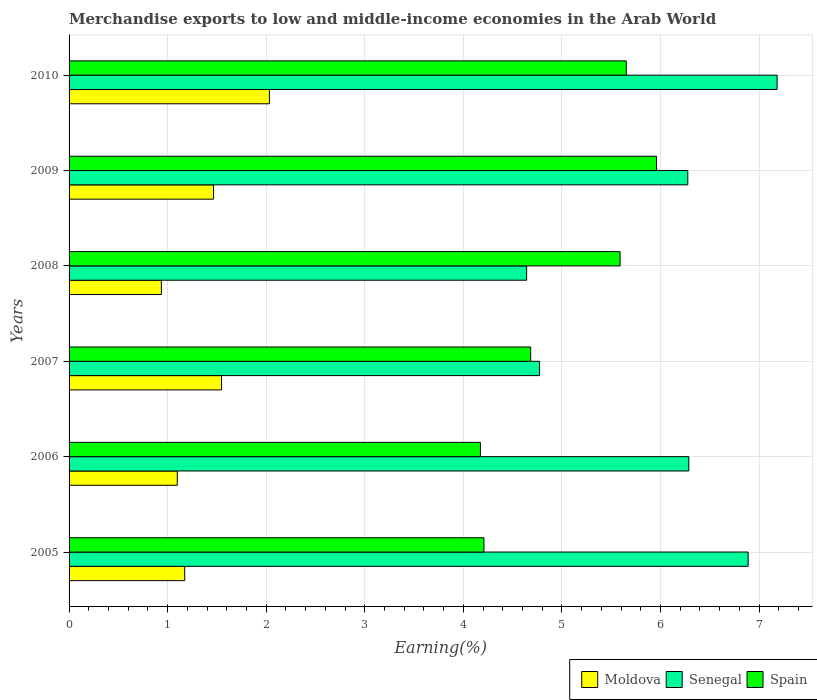Are the number of bars per tick equal to the number of legend labels?
Provide a short and direct response. Yes. Are the number of bars on each tick of the Y-axis equal?
Give a very brief answer. Yes. How many bars are there on the 1st tick from the bottom?
Offer a very short reply. 3. In how many cases, is the number of bars for a given year not equal to the number of legend labels?
Offer a terse response. 0. What is the percentage of amount earned from merchandise exports in Senegal in 2008?
Give a very brief answer. 4.64. Across all years, what is the maximum percentage of amount earned from merchandise exports in Moldova?
Offer a terse response. 2.03. Across all years, what is the minimum percentage of amount earned from merchandise exports in Moldova?
Make the answer very short. 0.94. In which year was the percentage of amount earned from merchandise exports in Senegal maximum?
Ensure brevity in your answer.  2010. In which year was the percentage of amount earned from merchandise exports in Spain minimum?
Provide a succinct answer. 2006. What is the total percentage of amount earned from merchandise exports in Moldova in the graph?
Your answer should be compact. 8.25. What is the difference between the percentage of amount earned from merchandise exports in Senegal in 2006 and that in 2008?
Keep it short and to the point. 1.65. What is the difference between the percentage of amount earned from merchandise exports in Senegal in 2006 and the percentage of amount earned from merchandise exports in Spain in 2009?
Your answer should be very brief. 0.33. What is the average percentage of amount earned from merchandise exports in Senegal per year?
Make the answer very short. 6.01. In the year 2008, what is the difference between the percentage of amount earned from merchandise exports in Spain and percentage of amount earned from merchandise exports in Senegal?
Make the answer very short. 0.95. In how many years, is the percentage of amount earned from merchandise exports in Moldova greater than 6.8 %?
Make the answer very short. 0. What is the ratio of the percentage of amount earned from merchandise exports in Spain in 2008 to that in 2009?
Provide a short and direct response. 0.94. What is the difference between the highest and the second highest percentage of amount earned from merchandise exports in Senegal?
Your answer should be very brief. 0.29. What is the difference between the highest and the lowest percentage of amount earned from merchandise exports in Spain?
Keep it short and to the point. 1.79. Is the sum of the percentage of amount earned from merchandise exports in Moldova in 2008 and 2010 greater than the maximum percentage of amount earned from merchandise exports in Spain across all years?
Keep it short and to the point. No. What does the 2nd bar from the top in 2007 represents?
Offer a very short reply. Senegal. Is it the case that in every year, the sum of the percentage of amount earned from merchandise exports in Moldova and percentage of amount earned from merchandise exports in Spain is greater than the percentage of amount earned from merchandise exports in Senegal?
Your answer should be compact. No. Are all the bars in the graph horizontal?
Your answer should be compact. Yes. How many years are there in the graph?
Ensure brevity in your answer.  6. What is the difference between two consecutive major ticks on the X-axis?
Keep it short and to the point. 1. Are the values on the major ticks of X-axis written in scientific E-notation?
Ensure brevity in your answer.  No. How many legend labels are there?
Provide a short and direct response. 3. What is the title of the graph?
Make the answer very short. Merchandise exports to low and middle-income economies in the Arab World. What is the label or title of the X-axis?
Provide a short and direct response. Earning(%). What is the label or title of the Y-axis?
Your answer should be very brief. Years. What is the Earning(%) in Moldova in 2005?
Provide a short and direct response. 1.17. What is the Earning(%) in Senegal in 2005?
Make the answer very short. 6.89. What is the Earning(%) in Spain in 2005?
Your response must be concise. 4.21. What is the Earning(%) of Moldova in 2006?
Provide a short and direct response. 1.1. What is the Earning(%) of Senegal in 2006?
Offer a very short reply. 6.29. What is the Earning(%) of Spain in 2006?
Keep it short and to the point. 4.17. What is the Earning(%) of Moldova in 2007?
Your answer should be compact. 1.55. What is the Earning(%) in Senegal in 2007?
Your response must be concise. 4.77. What is the Earning(%) in Spain in 2007?
Make the answer very short. 4.68. What is the Earning(%) of Moldova in 2008?
Provide a succinct answer. 0.94. What is the Earning(%) in Senegal in 2008?
Provide a succinct answer. 4.64. What is the Earning(%) in Spain in 2008?
Make the answer very short. 5.59. What is the Earning(%) of Moldova in 2009?
Offer a terse response. 1.47. What is the Earning(%) of Senegal in 2009?
Make the answer very short. 6.28. What is the Earning(%) in Spain in 2009?
Provide a short and direct response. 5.96. What is the Earning(%) in Moldova in 2010?
Ensure brevity in your answer.  2.03. What is the Earning(%) in Senegal in 2010?
Your answer should be very brief. 7.18. What is the Earning(%) of Spain in 2010?
Provide a short and direct response. 5.65. Across all years, what is the maximum Earning(%) of Moldova?
Provide a succinct answer. 2.03. Across all years, what is the maximum Earning(%) in Senegal?
Offer a very short reply. 7.18. Across all years, what is the maximum Earning(%) of Spain?
Your answer should be compact. 5.96. Across all years, what is the minimum Earning(%) in Moldova?
Ensure brevity in your answer.  0.94. Across all years, what is the minimum Earning(%) of Senegal?
Ensure brevity in your answer.  4.64. Across all years, what is the minimum Earning(%) of Spain?
Your answer should be very brief. 4.17. What is the total Earning(%) in Moldova in the graph?
Keep it short and to the point. 8.25. What is the total Earning(%) in Senegal in the graph?
Your answer should be compact. 36.05. What is the total Earning(%) of Spain in the graph?
Your answer should be very brief. 30.27. What is the difference between the Earning(%) in Moldova in 2005 and that in 2006?
Your answer should be very brief. 0.08. What is the difference between the Earning(%) of Senegal in 2005 and that in 2006?
Provide a short and direct response. 0.6. What is the difference between the Earning(%) in Spain in 2005 and that in 2006?
Your answer should be very brief. 0.04. What is the difference between the Earning(%) in Moldova in 2005 and that in 2007?
Make the answer very short. -0.37. What is the difference between the Earning(%) of Senegal in 2005 and that in 2007?
Provide a succinct answer. 2.12. What is the difference between the Earning(%) of Spain in 2005 and that in 2007?
Make the answer very short. -0.47. What is the difference between the Earning(%) of Moldova in 2005 and that in 2008?
Provide a succinct answer. 0.24. What is the difference between the Earning(%) in Senegal in 2005 and that in 2008?
Ensure brevity in your answer.  2.25. What is the difference between the Earning(%) in Spain in 2005 and that in 2008?
Ensure brevity in your answer.  -1.38. What is the difference between the Earning(%) in Moldova in 2005 and that in 2009?
Offer a terse response. -0.29. What is the difference between the Earning(%) in Senegal in 2005 and that in 2009?
Your answer should be very brief. 0.61. What is the difference between the Earning(%) in Spain in 2005 and that in 2009?
Keep it short and to the point. -1.75. What is the difference between the Earning(%) in Moldova in 2005 and that in 2010?
Offer a terse response. -0.86. What is the difference between the Earning(%) of Senegal in 2005 and that in 2010?
Offer a terse response. -0.29. What is the difference between the Earning(%) of Spain in 2005 and that in 2010?
Your answer should be compact. -1.44. What is the difference between the Earning(%) in Moldova in 2006 and that in 2007?
Make the answer very short. -0.45. What is the difference between the Earning(%) in Senegal in 2006 and that in 2007?
Your answer should be very brief. 1.51. What is the difference between the Earning(%) of Spain in 2006 and that in 2007?
Provide a succinct answer. -0.51. What is the difference between the Earning(%) of Moldova in 2006 and that in 2008?
Make the answer very short. 0.16. What is the difference between the Earning(%) in Senegal in 2006 and that in 2008?
Your answer should be compact. 1.65. What is the difference between the Earning(%) in Spain in 2006 and that in 2008?
Ensure brevity in your answer.  -1.42. What is the difference between the Earning(%) of Moldova in 2006 and that in 2009?
Make the answer very short. -0.37. What is the difference between the Earning(%) in Senegal in 2006 and that in 2009?
Your response must be concise. 0.01. What is the difference between the Earning(%) in Spain in 2006 and that in 2009?
Your answer should be compact. -1.79. What is the difference between the Earning(%) of Moldova in 2006 and that in 2010?
Ensure brevity in your answer.  -0.93. What is the difference between the Earning(%) in Senegal in 2006 and that in 2010?
Offer a terse response. -0.9. What is the difference between the Earning(%) of Spain in 2006 and that in 2010?
Make the answer very short. -1.48. What is the difference between the Earning(%) of Moldova in 2007 and that in 2008?
Give a very brief answer. 0.61. What is the difference between the Earning(%) in Senegal in 2007 and that in 2008?
Offer a terse response. 0.13. What is the difference between the Earning(%) of Spain in 2007 and that in 2008?
Offer a terse response. -0.91. What is the difference between the Earning(%) in Moldova in 2007 and that in 2009?
Your answer should be very brief. 0.08. What is the difference between the Earning(%) in Senegal in 2007 and that in 2009?
Keep it short and to the point. -1.5. What is the difference between the Earning(%) in Spain in 2007 and that in 2009?
Your response must be concise. -1.28. What is the difference between the Earning(%) in Moldova in 2007 and that in 2010?
Your answer should be very brief. -0.49. What is the difference between the Earning(%) in Senegal in 2007 and that in 2010?
Make the answer very short. -2.41. What is the difference between the Earning(%) of Spain in 2007 and that in 2010?
Ensure brevity in your answer.  -0.97. What is the difference between the Earning(%) of Moldova in 2008 and that in 2009?
Keep it short and to the point. -0.53. What is the difference between the Earning(%) of Senegal in 2008 and that in 2009?
Offer a terse response. -1.64. What is the difference between the Earning(%) in Spain in 2008 and that in 2009?
Provide a short and direct response. -0.37. What is the difference between the Earning(%) in Moldova in 2008 and that in 2010?
Offer a very short reply. -1.1. What is the difference between the Earning(%) of Senegal in 2008 and that in 2010?
Offer a terse response. -2.54. What is the difference between the Earning(%) in Spain in 2008 and that in 2010?
Give a very brief answer. -0.06. What is the difference between the Earning(%) in Moldova in 2009 and that in 2010?
Offer a very short reply. -0.57. What is the difference between the Earning(%) of Senegal in 2009 and that in 2010?
Ensure brevity in your answer.  -0.91. What is the difference between the Earning(%) of Spain in 2009 and that in 2010?
Provide a succinct answer. 0.31. What is the difference between the Earning(%) in Moldova in 2005 and the Earning(%) in Senegal in 2006?
Give a very brief answer. -5.11. What is the difference between the Earning(%) in Moldova in 2005 and the Earning(%) in Spain in 2006?
Offer a very short reply. -3. What is the difference between the Earning(%) in Senegal in 2005 and the Earning(%) in Spain in 2006?
Offer a terse response. 2.72. What is the difference between the Earning(%) of Moldova in 2005 and the Earning(%) of Senegal in 2007?
Your response must be concise. -3.6. What is the difference between the Earning(%) of Moldova in 2005 and the Earning(%) of Spain in 2007?
Ensure brevity in your answer.  -3.51. What is the difference between the Earning(%) in Senegal in 2005 and the Earning(%) in Spain in 2007?
Give a very brief answer. 2.21. What is the difference between the Earning(%) in Moldova in 2005 and the Earning(%) in Senegal in 2008?
Offer a very short reply. -3.47. What is the difference between the Earning(%) in Moldova in 2005 and the Earning(%) in Spain in 2008?
Ensure brevity in your answer.  -4.42. What is the difference between the Earning(%) of Senegal in 2005 and the Earning(%) of Spain in 2008?
Your answer should be compact. 1.3. What is the difference between the Earning(%) in Moldova in 2005 and the Earning(%) in Senegal in 2009?
Make the answer very short. -5.1. What is the difference between the Earning(%) in Moldova in 2005 and the Earning(%) in Spain in 2009?
Your answer should be very brief. -4.79. What is the difference between the Earning(%) in Senegal in 2005 and the Earning(%) in Spain in 2009?
Provide a short and direct response. 0.93. What is the difference between the Earning(%) of Moldova in 2005 and the Earning(%) of Senegal in 2010?
Provide a succinct answer. -6.01. What is the difference between the Earning(%) in Moldova in 2005 and the Earning(%) in Spain in 2010?
Your response must be concise. -4.48. What is the difference between the Earning(%) of Senegal in 2005 and the Earning(%) of Spain in 2010?
Offer a very short reply. 1.24. What is the difference between the Earning(%) of Moldova in 2006 and the Earning(%) of Senegal in 2007?
Give a very brief answer. -3.68. What is the difference between the Earning(%) of Moldova in 2006 and the Earning(%) of Spain in 2007?
Make the answer very short. -3.59. What is the difference between the Earning(%) in Senegal in 2006 and the Earning(%) in Spain in 2007?
Your answer should be very brief. 1.6. What is the difference between the Earning(%) in Moldova in 2006 and the Earning(%) in Senegal in 2008?
Your response must be concise. -3.54. What is the difference between the Earning(%) in Moldova in 2006 and the Earning(%) in Spain in 2008?
Your response must be concise. -4.49. What is the difference between the Earning(%) of Senegal in 2006 and the Earning(%) of Spain in 2008?
Your answer should be compact. 0.7. What is the difference between the Earning(%) of Moldova in 2006 and the Earning(%) of Senegal in 2009?
Make the answer very short. -5.18. What is the difference between the Earning(%) of Moldova in 2006 and the Earning(%) of Spain in 2009?
Provide a short and direct response. -4.86. What is the difference between the Earning(%) in Senegal in 2006 and the Earning(%) in Spain in 2009?
Offer a terse response. 0.33. What is the difference between the Earning(%) in Moldova in 2006 and the Earning(%) in Senegal in 2010?
Give a very brief answer. -6.09. What is the difference between the Earning(%) of Moldova in 2006 and the Earning(%) of Spain in 2010?
Your answer should be compact. -4.56. What is the difference between the Earning(%) of Senegal in 2006 and the Earning(%) of Spain in 2010?
Keep it short and to the point. 0.63. What is the difference between the Earning(%) of Moldova in 2007 and the Earning(%) of Senegal in 2008?
Ensure brevity in your answer.  -3.1. What is the difference between the Earning(%) of Moldova in 2007 and the Earning(%) of Spain in 2008?
Offer a terse response. -4.04. What is the difference between the Earning(%) of Senegal in 2007 and the Earning(%) of Spain in 2008?
Your answer should be compact. -0.82. What is the difference between the Earning(%) of Moldova in 2007 and the Earning(%) of Senegal in 2009?
Give a very brief answer. -4.73. What is the difference between the Earning(%) in Moldova in 2007 and the Earning(%) in Spain in 2009?
Your answer should be compact. -4.41. What is the difference between the Earning(%) of Senegal in 2007 and the Earning(%) of Spain in 2009?
Make the answer very short. -1.19. What is the difference between the Earning(%) of Moldova in 2007 and the Earning(%) of Senegal in 2010?
Provide a succinct answer. -5.64. What is the difference between the Earning(%) in Moldova in 2007 and the Earning(%) in Spain in 2010?
Make the answer very short. -4.11. What is the difference between the Earning(%) in Senegal in 2007 and the Earning(%) in Spain in 2010?
Offer a very short reply. -0.88. What is the difference between the Earning(%) in Moldova in 2008 and the Earning(%) in Senegal in 2009?
Your answer should be compact. -5.34. What is the difference between the Earning(%) of Moldova in 2008 and the Earning(%) of Spain in 2009?
Your response must be concise. -5.02. What is the difference between the Earning(%) in Senegal in 2008 and the Earning(%) in Spain in 2009?
Make the answer very short. -1.32. What is the difference between the Earning(%) in Moldova in 2008 and the Earning(%) in Senegal in 2010?
Offer a very short reply. -6.25. What is the difference between the Earning(%) of Moldova in 2008 and the Earning(%) of Spain in 2010?
Your answer should be very brief. -4.72. What is the difference between the Earning(%) of Senegal in 2008 and the Earning(%) of Spain in 2010?
Provide a short and direct response. -1.01. What is the difference between the Earning(%) of Moldova in 2009 and the Earning(%) of Senegal in 2010?
Ensure brevity in your answer.  -5.72. What is the difference between the Earning(%) in Moldova in 2009 and the Earning(%) in Spain in 2010?
Offer a very short reply. -4.19. What is the difference between the Earning(%) in Senegal in 2009 and the Earning(%) in Spain in 2010?
Keep it short and to the point. 0.62. What is the average Earning(%) in Moldova per year?
Provide a succinct answer. 1.38. What is the average Earning(%) in Senegal per year?
Provide a succinct answer. 6.01. What is the average Earning(%) of Spain per year?
Your response must be concise. 5.04. In the year 2005, what is the difference between the Earning(%) in Moldova and Earning(%) in Senegal?
Provide a short and direct response. -5.72. In the year 2005, what is the difference between the Earning(%) in Moldova and Earning(%) in Spain?
Ensure brevity in your answer.  -3.04. In the year 2005, what is the difference between the Earning(%) in Senegal and Earning(%) in Spain?
Give a very brief answer. 2.68. In the year 2006, what is the difference between the Earning(%) in Moldova and Earning(%) in Senegal?
Your answer should be compact. -5.19. In the year 2006, what is the difference between the Earning(%) in Moldova and Earning(%) in Spain?
Give a very brief answer. -3.08. In the year 2006, what is the difference between the Earning(%) of Senegal and Earning(%) of Spain?
Give a very brief answer. 2.11. In the year 2007, what is the difference between the Earning(%) of Moldova and Earning(%) of Senegal?
Provide a succinct answer. -3.23. In the year 2007, what is the difference between the Earning(%) in Moldova and Earning(%) in Spain?
Your answer should be compact. -3.14. In the year 2007, what is the difference between the Earning(%) of Senegal and Earning(%) of Spain?
Provide a succinct answer. 0.09. In the year 2008, what is the difference between the Earning(%) in Moldova and Earning(%) in Senegal?
Offer a terse response. -3.71. In the year 2008, what is the difference between the Earning(%) of Moldova and Earning(%) of Spain?
Ensure brevity in your answer.  -4.65. In the year 2008, what is the difference between the Earning(%) of Senegal and Earning(%) of Spain?
Provide a succinct answer. -0.95. In the year 2009, what is the difference between the Earning(%) of Moldova and Earning(%) of Senegal?
Your response must be concise. -4.81. In the year 2009, what is the difference between the Earning(%) of Moldova and Earning(%) of Spain?
Give a very brief answer. -4.49. In the year 2009, what is the difference between the Earning(%) of Senegal and Earning(%) of Spain?
Your response must be concise. 0.32. In the year 2010, what is the difference between the Earning(%) of Moldova and Earning(%) of Senegal?
Offer a very short reply. -5.15. In the year 2010, what is the difference between the Earning(%) in Moldova and Earning(%) in Spain?
Ensure brevity in your answer.  -3.62. In the year 2010, what is the difference between the Earning(%) in Senegal and Earning(%) in Spain?
Ensure brevity in your answer.  1.53. What is the ratio of the Earning(%) in Moldova in 2005 to that in 2006?
Your answer should be very brief. 1.07. What is the ratio of the Earning(%) in Senegal in 2005 to that in 2006?
Keep it short and to the point. 1.1. What is the ratio of the Earning(%) of Spain in 2005 to that in 2006?
Provide a succinct answer. 1.01. What is the ratio of the Earning(%) of Moldova in 2005 to that in 2007?
Ensure brevity in your answer.  0.76. What is the ratio of the Earning(%) in Senegal in 2005 to that in 2007?
Your answer should be very brief. 1.44. What is the ratio of the Earning(%) in Spain in 2005 to that in 2007?
Your answer should be compact. 0.9. What is the ratio of the Earning(%) in Moldova in 2005 to that in 2008?
Offer a very short reply. 1.25. What is the ratio of the Earning(%) of Senegal in 2005 to that in 2008?
Offer a very short reply. 1.48. What is the ratio of the Earning(%) of Spain in 2005 to that in 2008?
Offer a terse response. 0.75. What is the ratio of the Earning(%) in Moldova in 2005 to that in 2009?
Your response must be concise. 0.8. What is the ratio of the Earning(%) in Senegal in 2005 to that in 2009?
Give a very brief answer. 1.1. What is the ratio of the Earning(%) of Spain in 2005 to that in 2009?
Make the answer very short. 0.71. What is the ratio of the Earning(%) of Moldova in 2005 to that in 2010?
Provide a succinct answer. 0.58. What is the ratio of the Earning(%) in Senegal in 2005 to that in 2010?
Make the answer very short. 0.96. What is the ratio of the Earning(%) in Spain in 2005 to that in 2010?
Your answer should be very brief. 0.74. What is the ratio of the Earning(%) in Moldova in 2006 to that in 2007?
Keep it short and to the point. 0.71. What is the ratio of the Earning(%) in Senegal in 2006 to that in 2007?
Your answer should be very brief. 1.32. What is the ratio of the Earning(%) in Spain in 2006 to that in 2007?
Give a very brief answer. 0.89. What is the ratio of the Earning(%) in Moldova in 2006 to that in 2008?
Give a very brief answer. 1.17. What is the ratio of the Earning(%) in Senegal in 2006 to that in 2008?
Make the answer very short. 1.35. What is the ratio of the Earning(%) in Spain in 2006 to that in 2008?
Ensure brevity in your answer.  0.75. What is the ratio of the Earning(%) of Moldova in 2006 to that in 2009?
Your response must be concise. 0.75. What is the ratio of the Earning(%) of Senegal in 2006 to that in 2009?
Offer a terse response. 1. What is the ratio of the Earning(%) in Spain in 2006 to that in 2009?
Offer a very short reply. 0.7. What is the ratio of the Earning(%) of Moldova in 2006 to that in 2010?
Your answer should be very brief. 0.54. What is the ratio of the Earning(%) in Senegal in 2006 to that in 2010?
Keep it short and to the point. 0.88. What is the ratio of the Earning(%) of Spain in 2006 to that in 2010?
Provide a short and direct response. 0.74. What is the ratio of the Earning(%) in Moldova in 2007 to that in 2008?
Your answer should be very brief. 1.65. What is the ratio of the Earning(%) of Senegal in 2007 to that in 2008?
Give a very brief answer. 1.03. What is the ratio of the Earning(%) of Spain in 2007 to that in 2008?
Offer a very short reply. 0.84. What is the ratio of the Earning(%) of Moldova in 2007 to that in 2009?
Ensure brevity in your answer.  1.06. What is the ratio of the Earning(%) in Senegal in 2007 to that in 2009?
Make the answer very short. 0.76. What is the ratio of the Earning(%) of Spain in 2007 to that in 2009?
Your response must be concise. 0.79. What is the ratio of the Earning(%) in Moldova in 2007 to that in 2010?
Give a very brief answer. 0.76. What is the ratio of the Earning(%) in Senegal in 2007 to that in 2010?
Keep it short and to the point. 0.66. What is the ratio of the Earning(%) of Spain in 2007 to that in 2010?
Provide a short and direct response. 0.83. What is the ratio of the Earning(%) in Moldova in 2008 to that in 2009?
Provide a succinct answer. 0.64. What is the ratio of the Earning(%) in Senegal in 2008 to that in 2009?
Give a very brief answer. 0.74. What is the ratio of the Earning(%) in Spain in 2008 to that in 2009?
Ensure brevity in your answer.  0.94. What is the ratio of the Earning(%) in Moldova in 2008 to that in 2010?
Give a very brief answer. 0.46. What is the ratio of the Earning(%) of Senegal in 2008 to that in 2010?
Your response must be concise. 0.65. What is the ratio of the Earning(%) in Spain in 2008 to that in 2010?
Ensure brevity in your answer.  0.99. What is the ratio of the Earning(%) of Moldova in 2009 to that in 2010?
Make the answer very short. 0.72. What is the ratio of the Earning(%) of Senegal in 2009 to that in 2010?
Provide a succinct answer. 0.87. What is the ratio of the Earning(%) of Spain in 2009 to that in 2010?
Give a very brief answer. 1.05. What is the difference between the highest and the second highest Earning(%) of Moldova?
Your answer should be compact. 0.49. What is the difference between the highest and the second highest Earning(%) of Senegal?
Ensure brevity in your answer.  0.29. What is the difference between the highest and the second highest Earning(%) in Spain?
Offer a terse response. 0.31. What is the difference between the highest and the lowest Earning(%) in Moldova?
Offer a very short reply. 1.1. What is the difference between the highest and the lowest Earning(%) in Senegal?
Make the answer very short. 2.54. What is the difference between the highest and the lowest Earning(%) in Spain?
Provide a short and direct response. 1.79. 